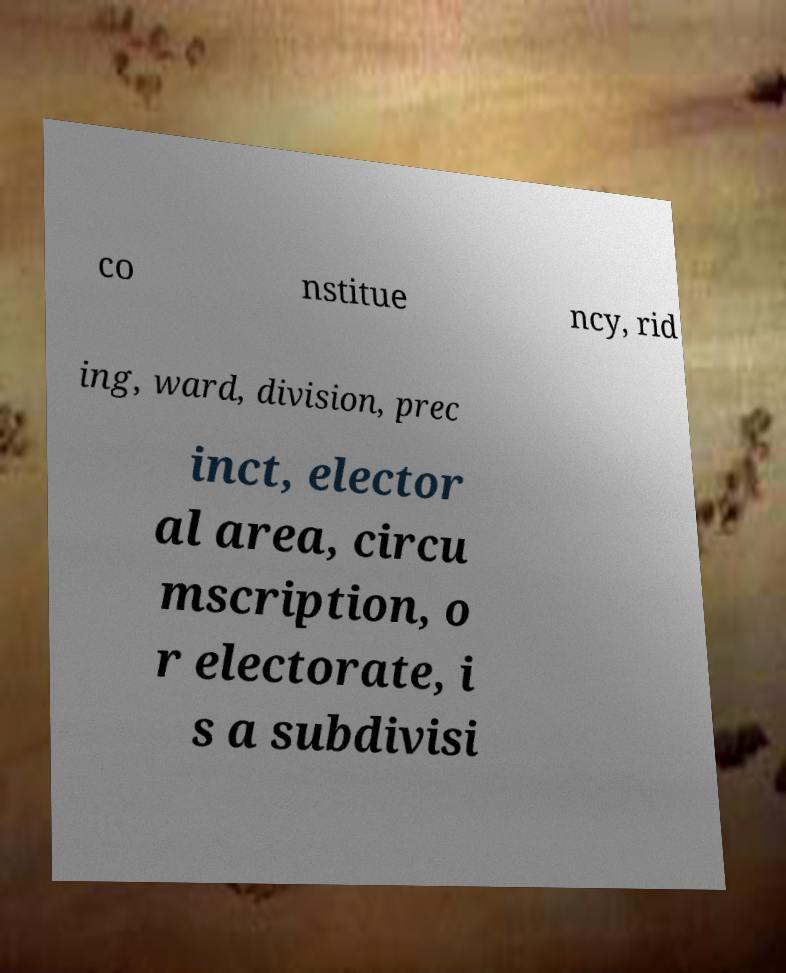For documentation purposes, I need the text within this image transcribed. Could you provide that? co nstitue ncy, rid ing, ward, division, prec inct, elector al area, circu mscription, o r electorate, i s a subdivisi 